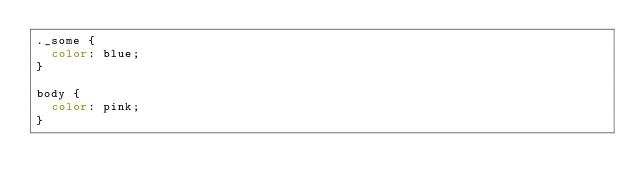<code> <loc_0><loc_0><loc_500><loc_500><_CSS_>._some {
  color: blue;
}

body {
  color: pink;
}
</code> 